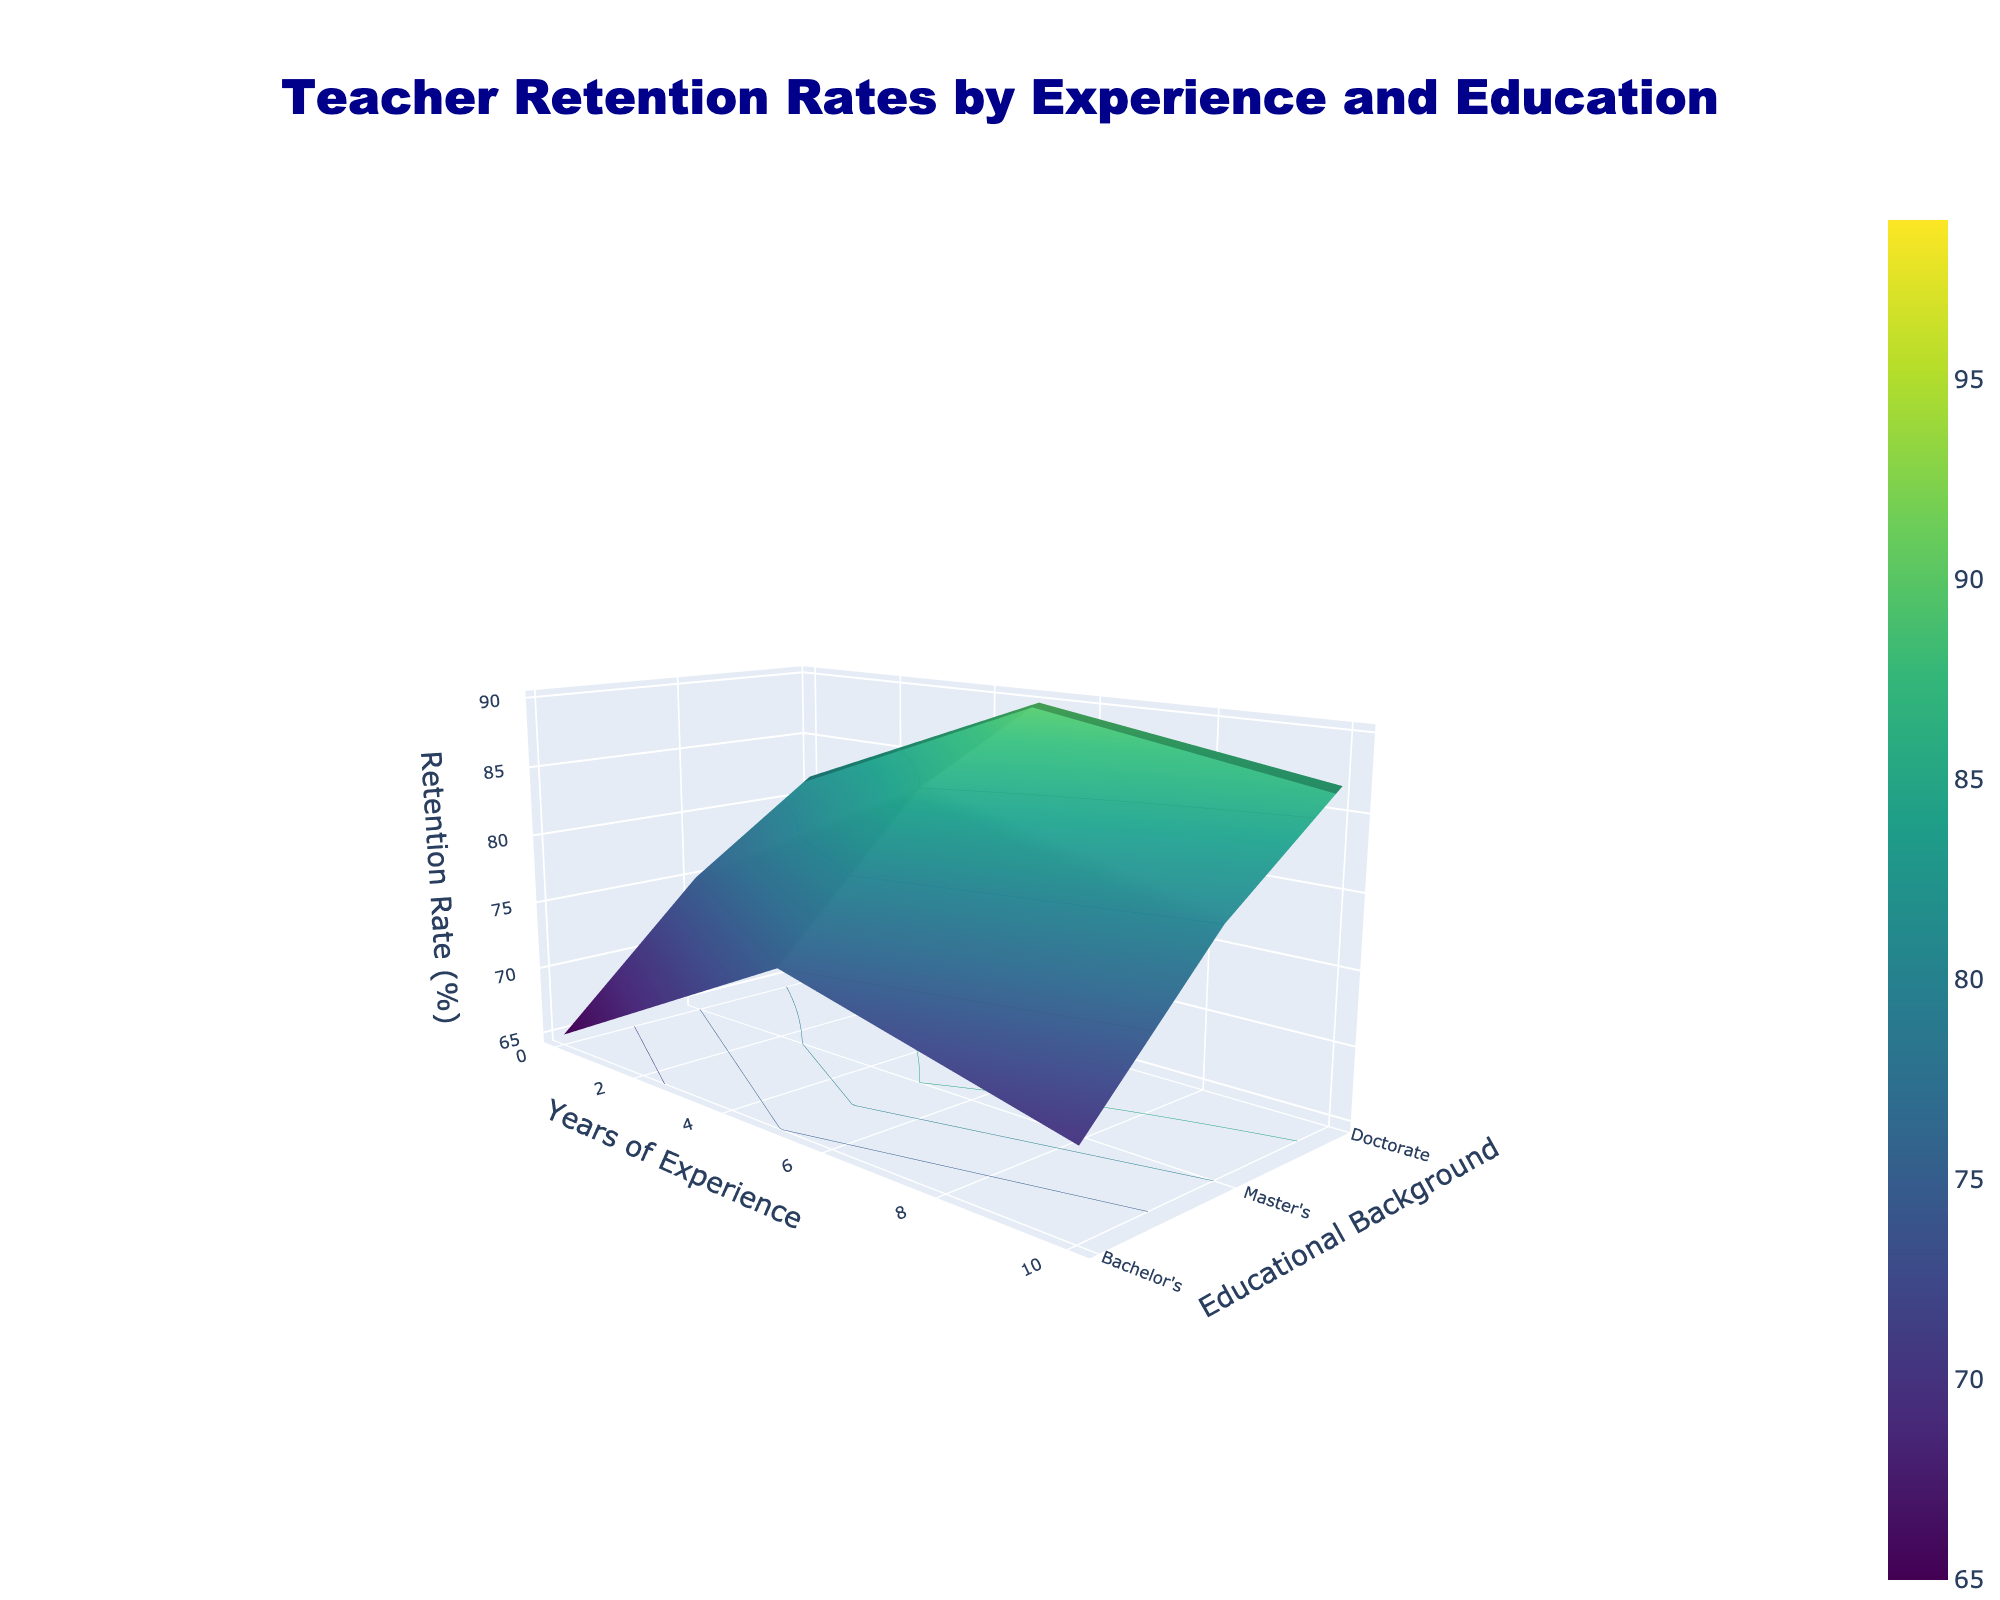What's the title of the figure? The title can be found at the top center of the figure. Here, the title is "Teacher Retention Rates by Experience and Education".
Answer: Teacher Retention Rates by Experience and Education What is on the x-axis? The x-axis, labeled at the bottom front of the 3D surface plot, represents the "Years of Experience".
Answer: Years of Experience What educational background shows the highest teacher retention rate? By observing the peak value on the z-axis, we can see that the "Doctorate" educational background reaches the highest point on the plot.
Answer: Doctorate Which combination of years of experience and educational background has the lowest retention rate? The lowest point on the 3D surface plot corresponds to "0 years of experience" and "Bachelor's" degree, as indicated by the position and height of the plot.
Answer: 0 years of experience and Bachelor's degree Compare the retention rate between Master's and Bachelor's degree at 10 years of experience. At 10 years of experience, locate the respective points for "Master's" and "Bachelor's" on the plot. The retention rate for Master's is 87%, and for Bachelor's is 82%, thus Master's is higher.
Answer: Master's is higher How does the retention rate change with years of experience for a Doctorate degree? Follow the contour of the Doctorate data points along the years of experience axis. We see a general increase from 75% at 0 years to 99% at 30 years of experience.
Answer: It increases What is the average retention rate for Master's degree across all years of experience? First, identify the retention rates for Master's degree: 70, 80, 87, 92, 95, 96, 97. Sum these values (70+80+87+92+95+96+97=517) and divide by the number of data points, which is 7. 517 ÷ 7 = 73.857.
Answer: 73.857 Is the retention rate consistently increasing with more years of experience for all educational backgrounds? Visually check the trend lines on the surface plot for all three educational backgrounds. The plot indicates a general upward trend across all experience levels.
Answer: Yes 